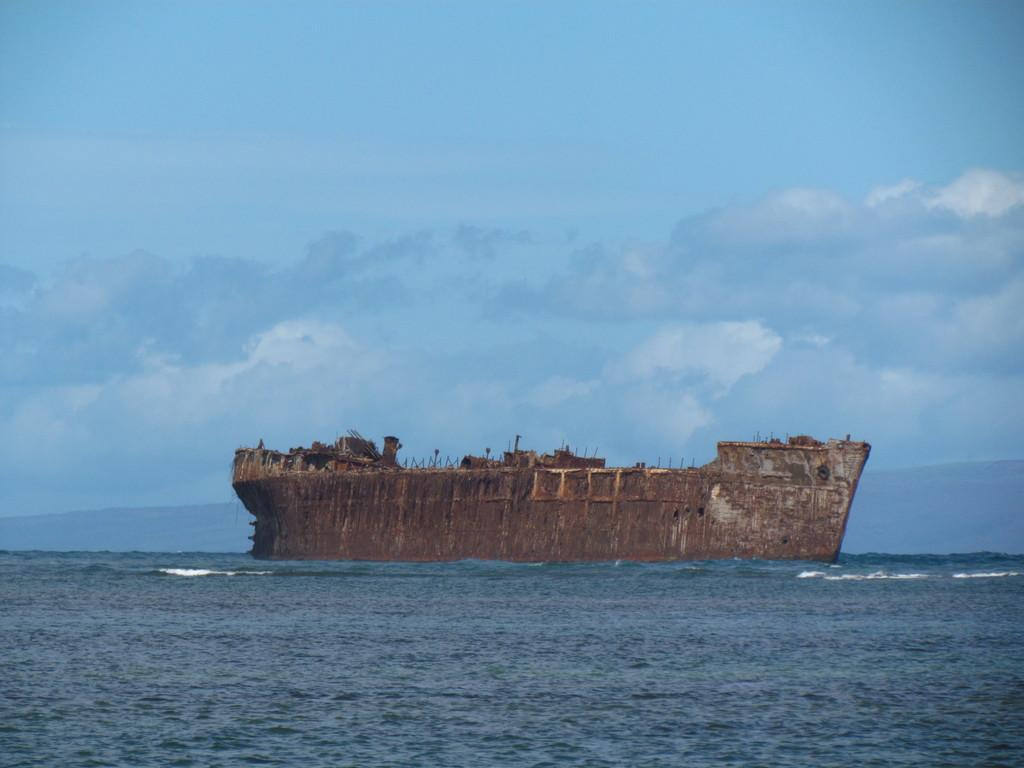What type of vehicle is in the image? There is a rusted ship in the image. Where is the ship located? The ship is on the water. What can be seen in the background of the image? The sky is visible behind the ship. What type of noise can be heard coming from the ship in the image? There is no indication of any noise in the image, as it is a still photograph. 